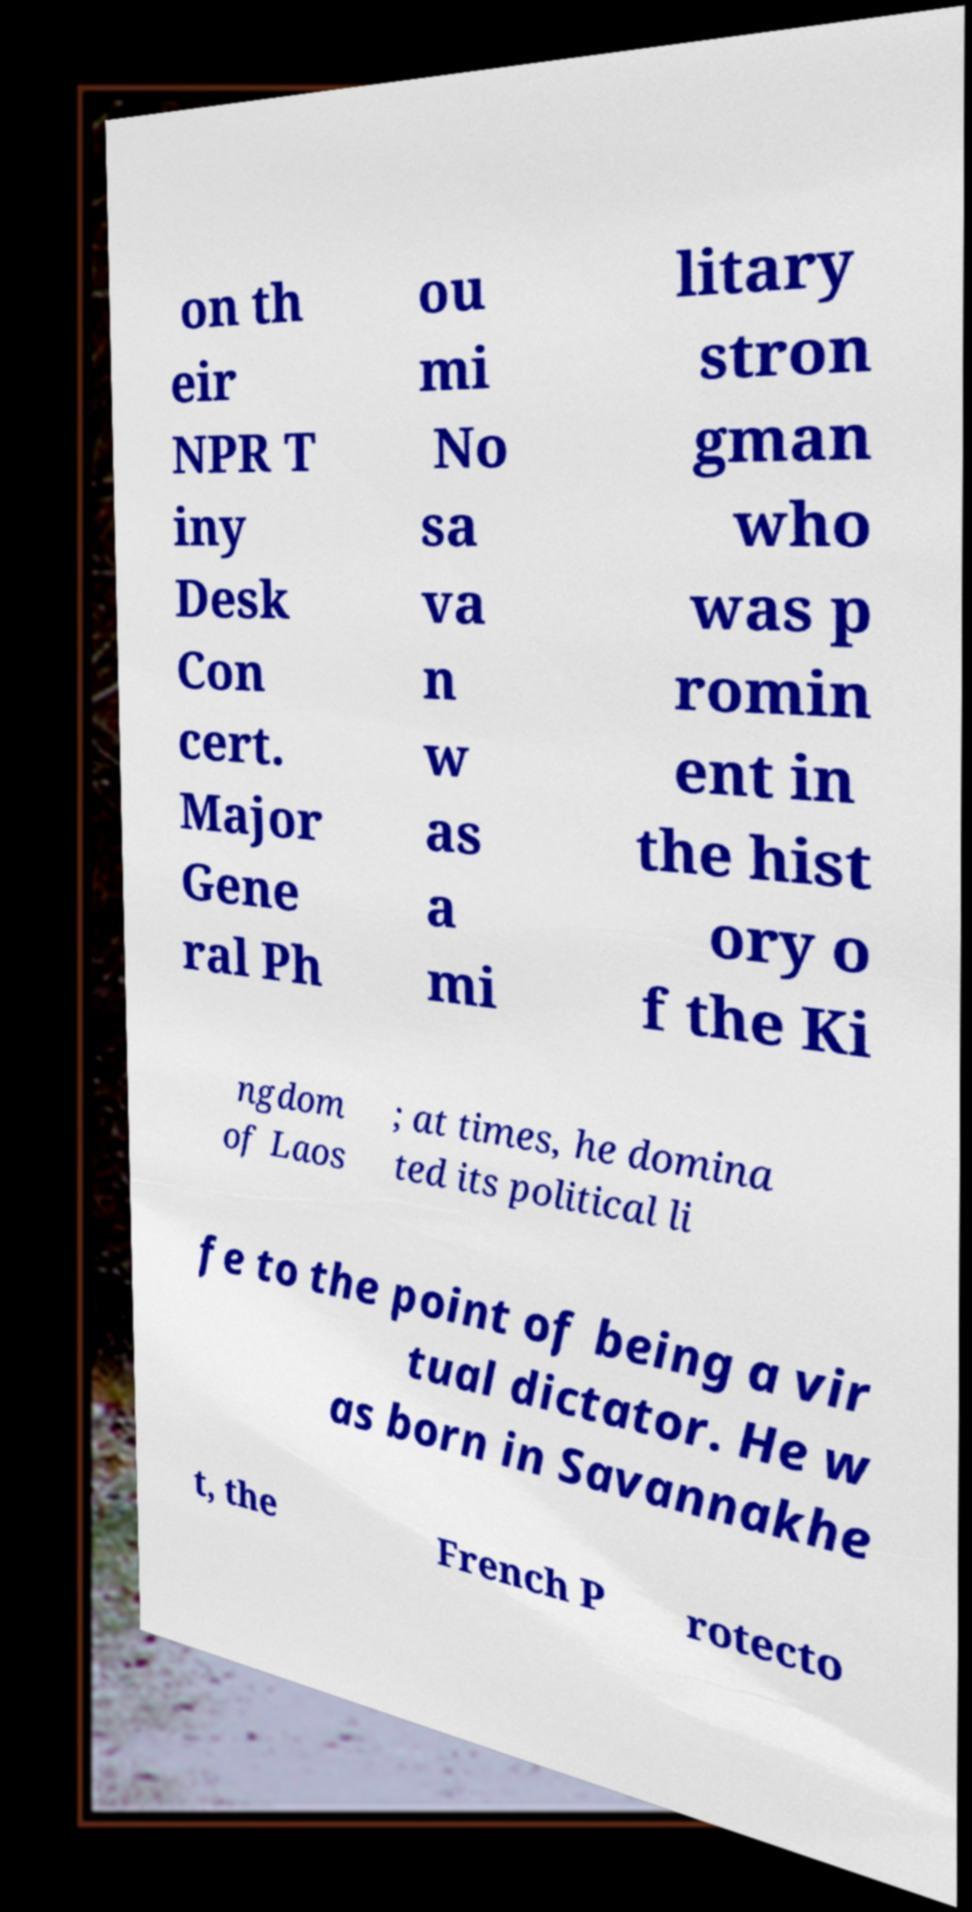I need the written content from this picture converted into text. Can you do that? on th eir NPR T iny Desk Con cert. Major Gene ral Ph ou mi No sa va n w as a mi litary stron gman who was p romin ent in the hist ory o f the Ki ngdom of Laos ; at times, he domina ted its political li fe to the point of being a vir tual dictator. He w as born in Savannakhe t, the French P rotecto 